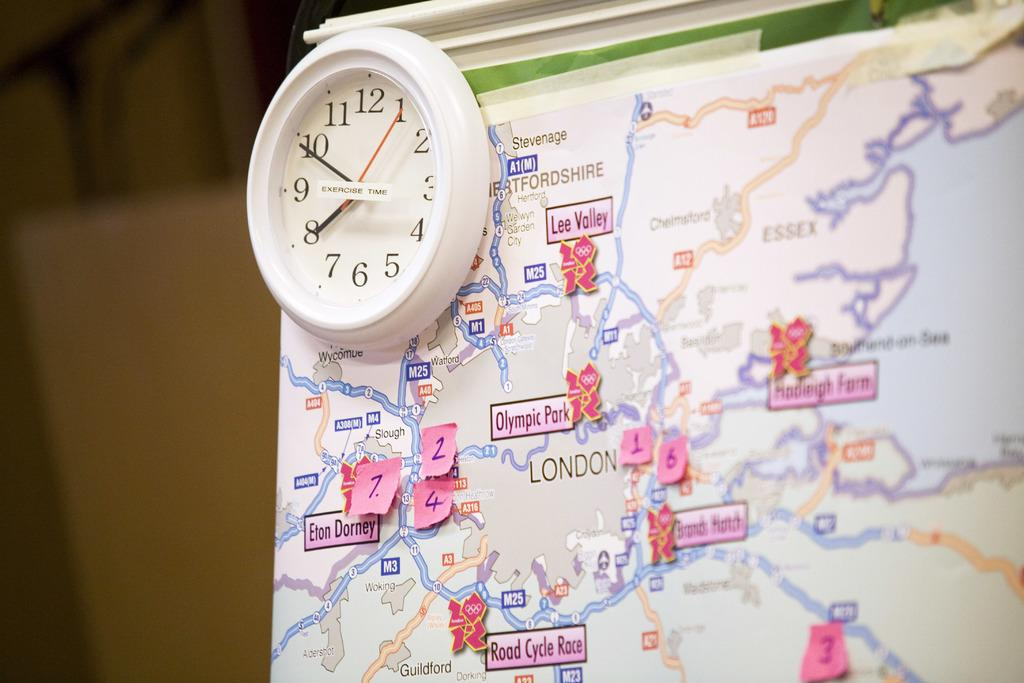<image>
Give a short and clear explanation of the subsequent image. A map of London has small post it notes with numbers on them attached to it. 